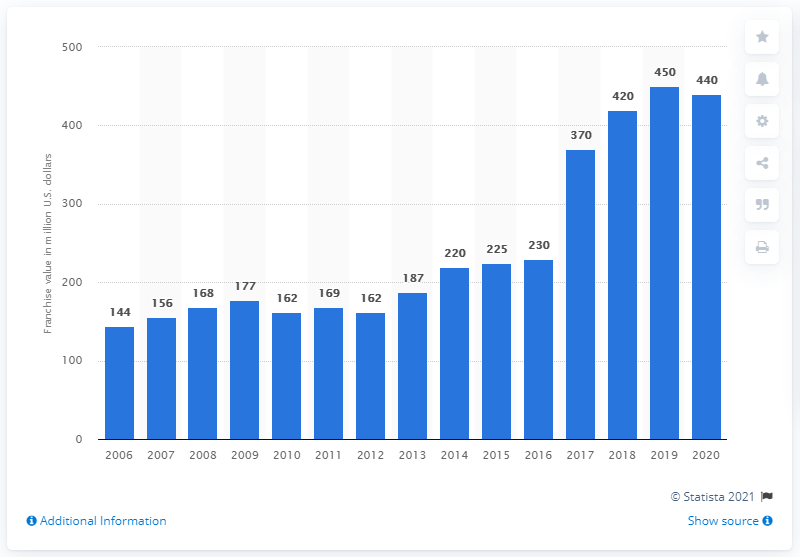Identify some key points in this picture. The value of the Carolina Hurricanes franchise in 2020 was estimated to be approximately 440 million dollars. 